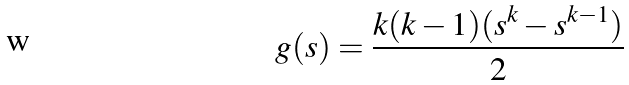<formula> <loc_0><loc_0><loc_500><loc_500>g ( s ) = \frac { k ( k - 1 ) ( s ^ { k } - s ^ { k - 1 } ) } { 2 }</formula> 